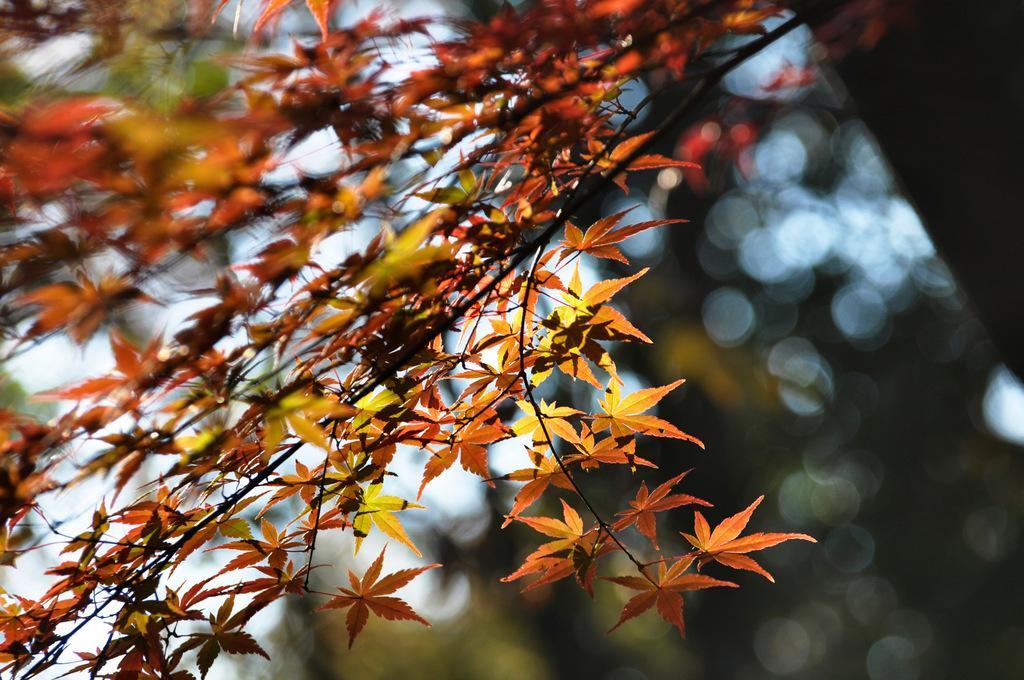How would you summarize this image in a sentence or two? In this image we can see the branch of a tree with some leaves. 